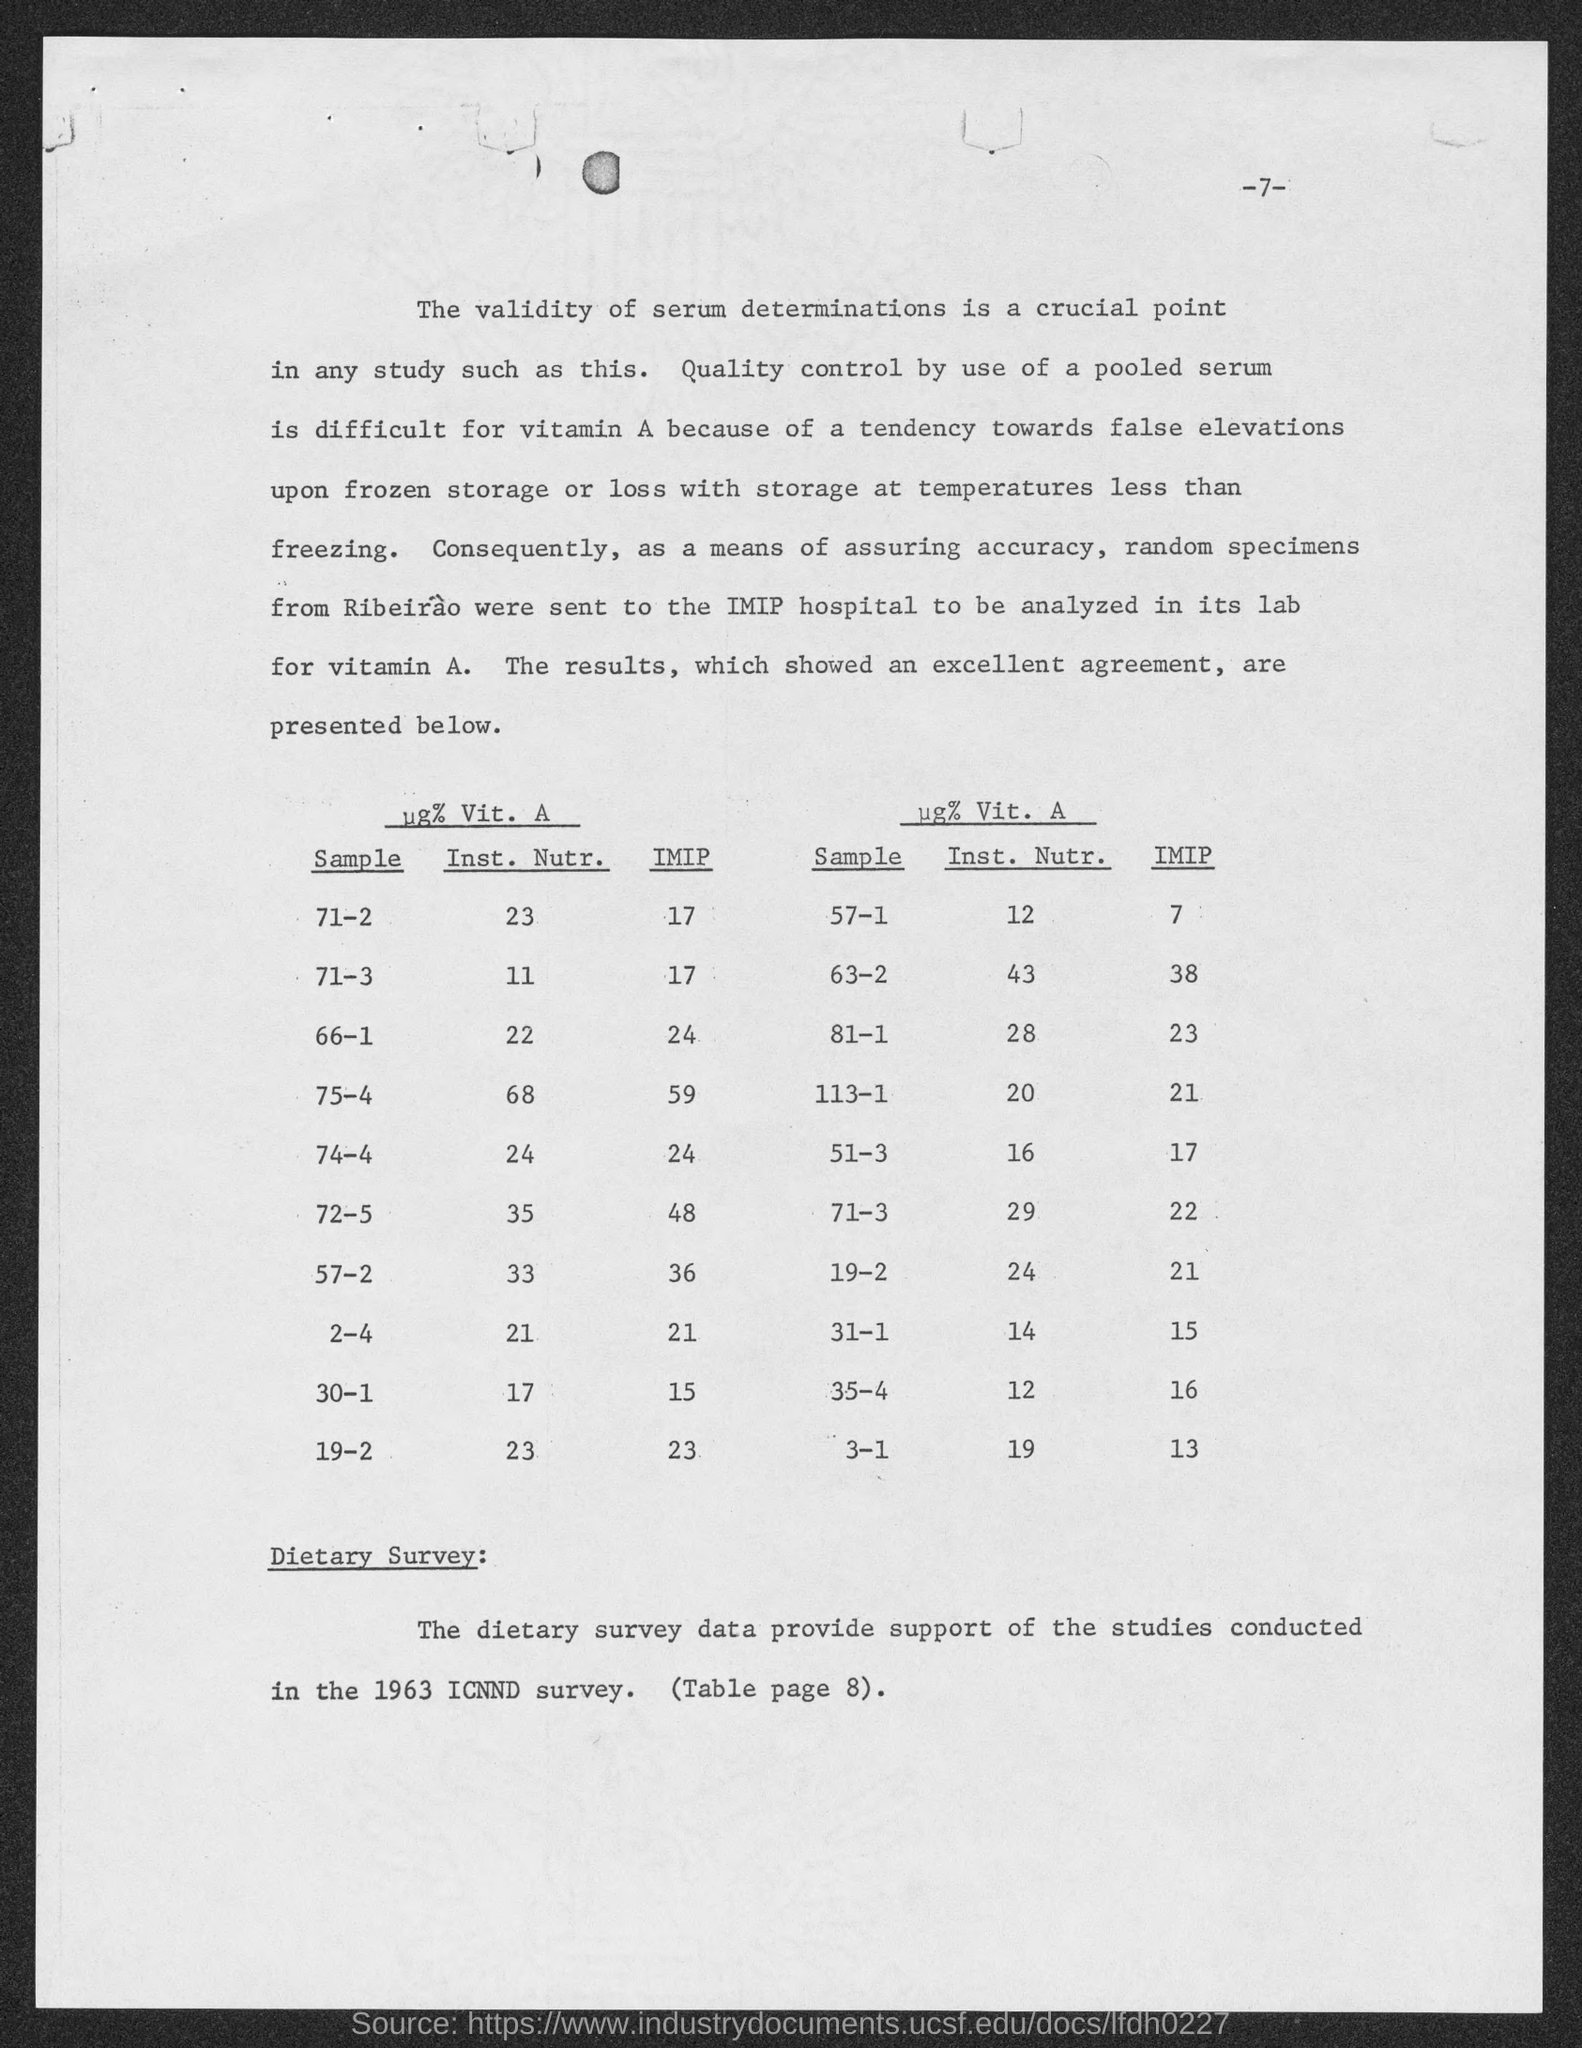What is the IMIP for Sample 71-2?
Your answer should be very brief. 17. What is the IMIP for Sample 71-3?
Keep it short and to the point. 17. What is the IMIP for Sample 66-1?
Your answer should be very brief. 24. What is the IMIP for Sample 57-1?
Provide a succinct answer. 7. What is the IMIP for Sample 75-4?
Give a very brief answer. 59. What is the IMIP for Sample 74-4?
Provide a succinct answer. 24. What is the IMIP for Sample 72-5?
Provide a succinct answer. 48. What is the IMIP for Sample 57-2?
Provide a short and direct response. 36. What is the IMIP for Sample 2-4?
Offer a very short reply. 21. What is the IMIP for Sample 30-1?
Give a very brief answer. 15. 